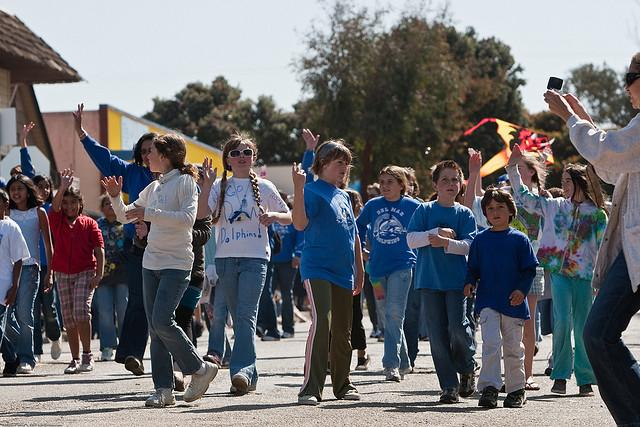Why is the woman on the right holding an object in her hands? Please explain your reasoning. taking photos. The woman is taking photos. 